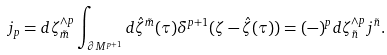Convert formula to latex. <formula><loc_0><loc_0><loc_500><loc_500>j _ { p } = d \zeta _ { \tilde { m } } ^ { \wedge p } \int _ { \partial M ^ { p + 1 } } d \hat { \zeta } ^ { \tilde { m } } ( \tau ) \delta ^ { p + 1 } ( \zeta - \hat { \zeta } ( \tau ) ) = ( - ) ^ { p } d \zeta _ { \tilde { n } } ^ { \wedge p } j ^ { \tilde { n } } .</formula> 